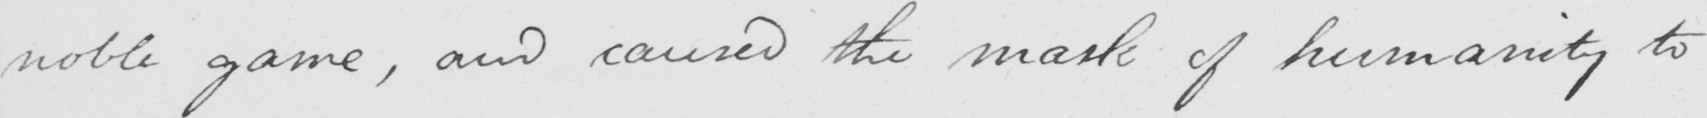What does this handwritten line say? noble game , and caused the mask of humanity to 